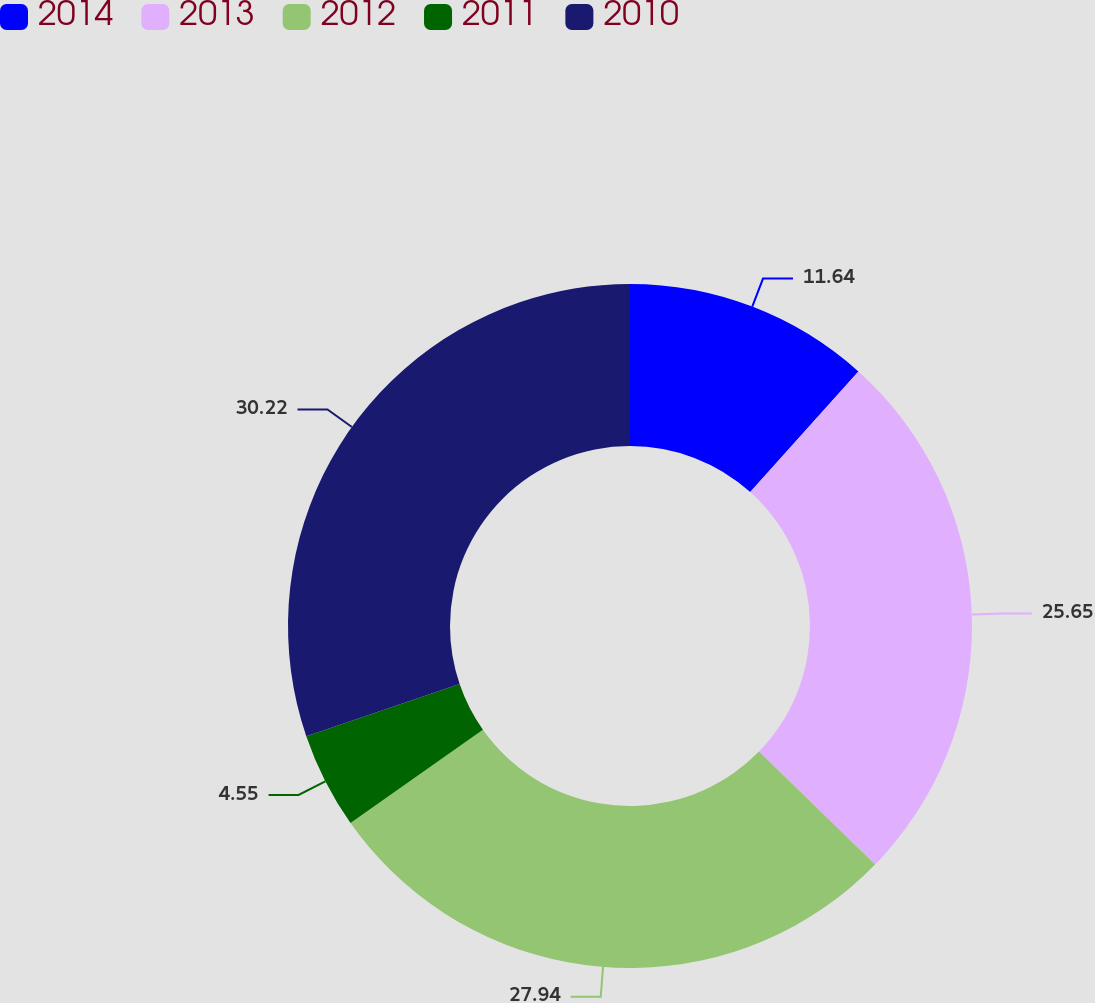<chart> <loc_0><loc_0><loc_500><loc_500><pie_chart><fcel>2014<fcel>2013<fcel>2012<fcel>2011<fcel>2010<nl><fcel>11.64%<fcel>25.65%<fcel>27.94%<fcel>4.55%<fcel>30.23%<nl></chart> 